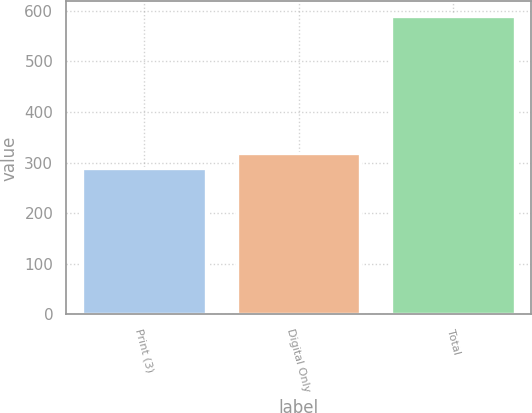Convert chart to OTSL. <chart><loc_0><loc_0><loc_500><loc_500><bar_chart><fcel>Print (3)<fcel>Digital Only<fcel>Total<nl><fcel>290<fcel>319.9<fcel>589<nl></chart> 